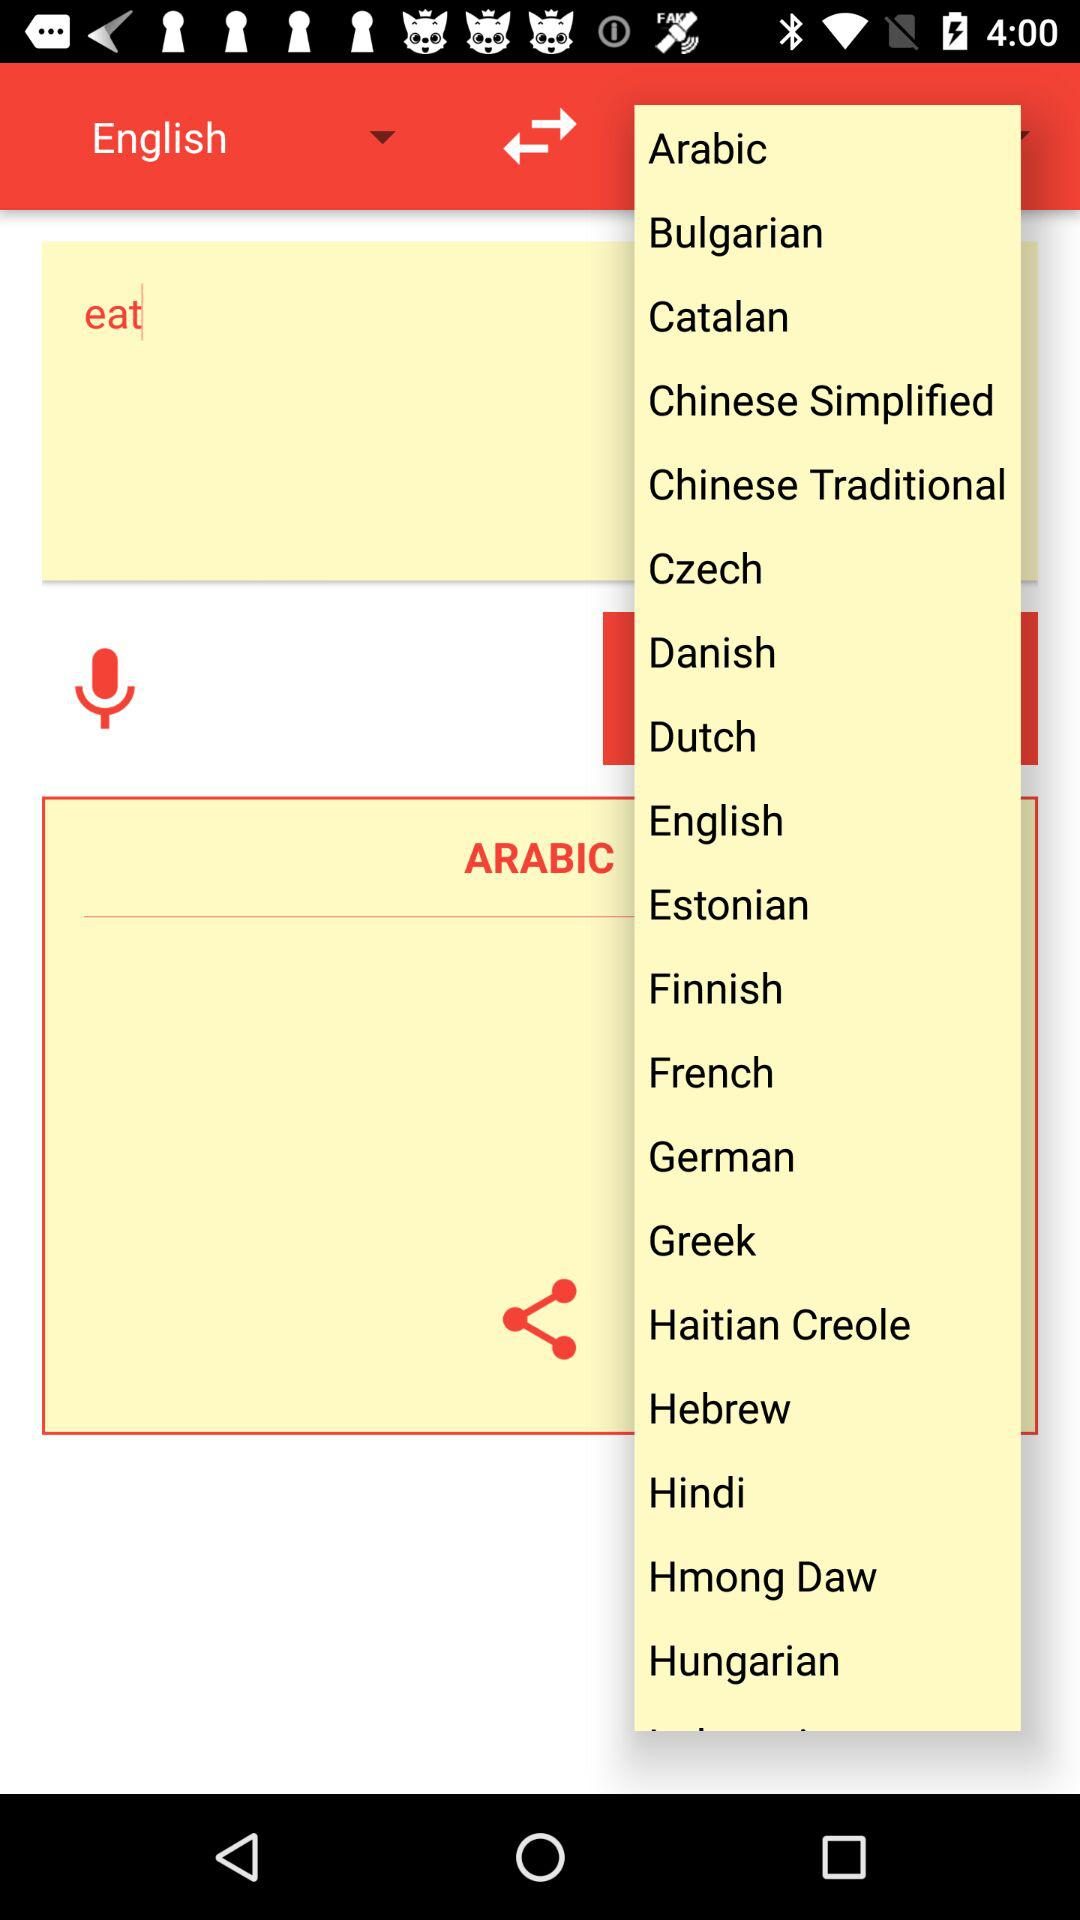What is written in the text field? The written text is "eat". 